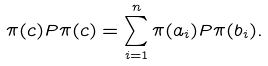Convert formula to latex. <formula><loc_0><loc_0><loc_500><loc_500>\pi ( c ) P \pi ( c ) = \sum _ { i = 1 } ^ { n } \pi ( a _ { i } ) P \pi ( b _ { i } ) .</formula> 